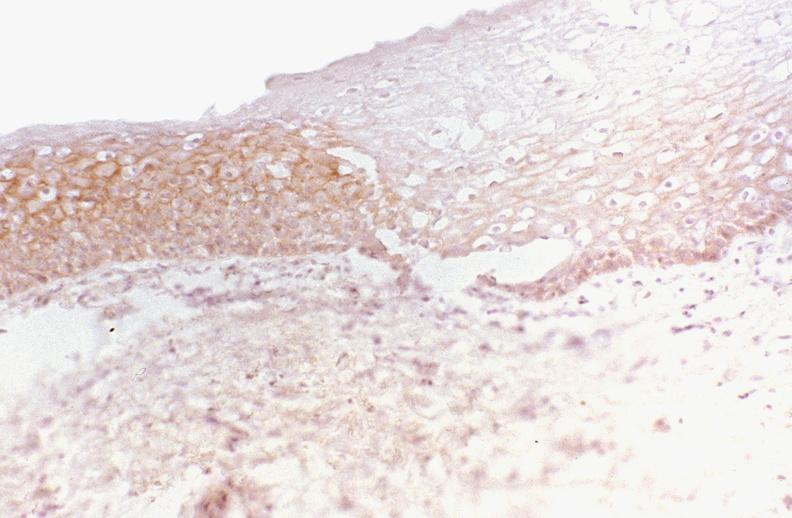s gastrointestinal present?
Answer the question using a single word or phrase. Yes 